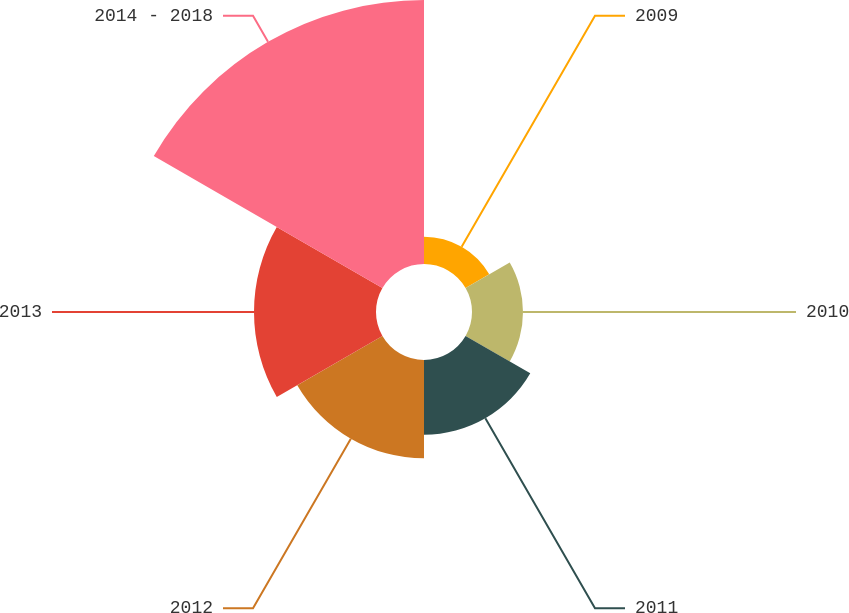Convert chart. <chart><loc_0><loc_0><loc_500><loc_500><pie_chart><fcel>2009<fcel>2010<fcel>2011<fcel>2012<fcel>2013<fcel>2014 - 2018<nl><fcel>4.29%<fcel>8.0%<fcel>11.72%<fcel>15.43%<fcel>19.14%<fcel>41.42%<nl></chart> 